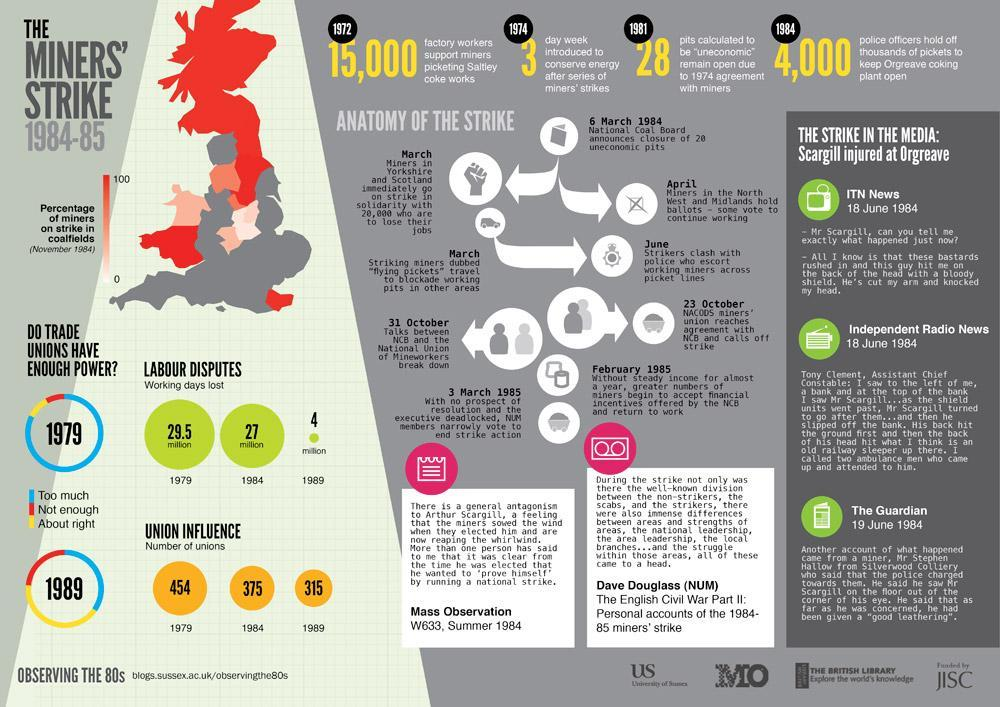When was 3 day week introduced to conserve energy after series of miners' strikes?
Answer the question with a short phrase. 1974 How many trade unions were on  the Miners' Strike in 1989? 315 How many trade unions were on the Miners' Strike in 1979? 454 How many working days were lost due to labour disputes in 1989? 4 million How many working days were lost due to labour disputes in 1984? 27 million 